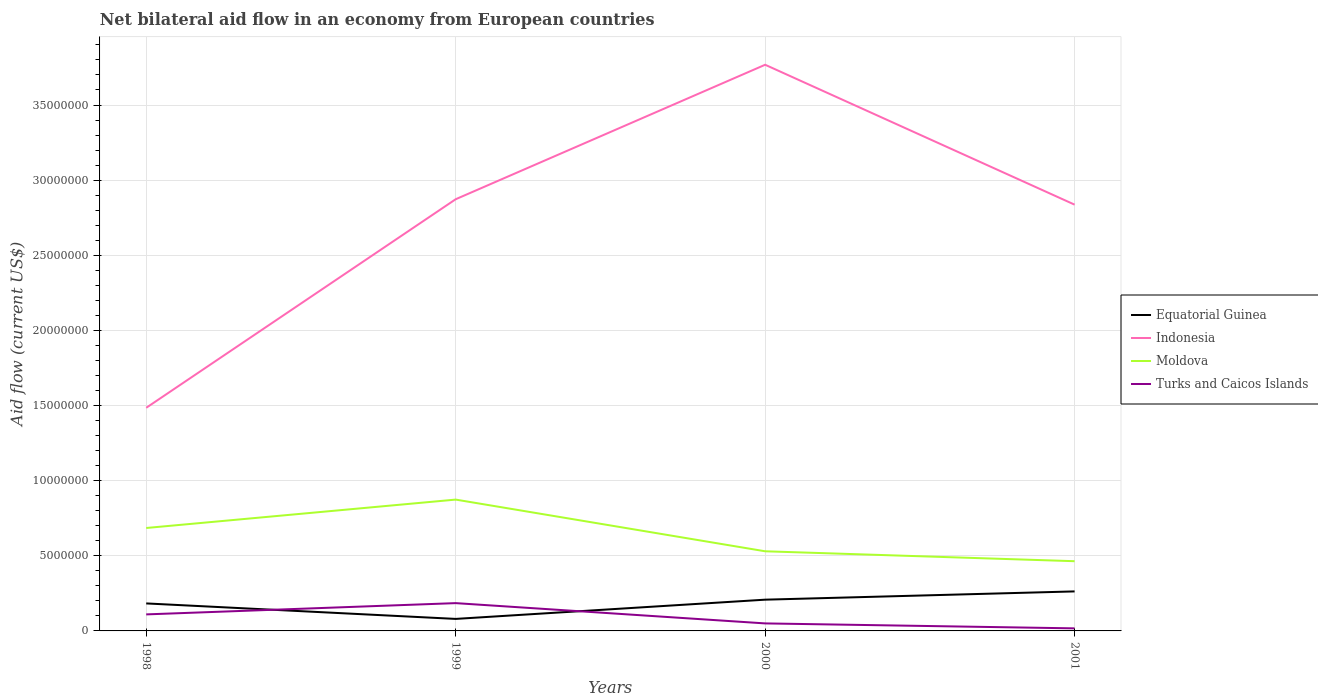Does the line corresponding to Equatorial Guinea intersect with the line corresponding to Indonesia?
Offer a very short reply. No. Across all years, what is the maximum net bilateral aid flow in Turks and Caicos Islands?
Make the answer very short. 1.70e+05. What is the total net bilateral aid flow in Equatorial Guinea in the graph?
Your answer should be very brief. 1.03e+06. What is the difference between the highest and the second highest net bilateral aid flow in Moldova?
Your answer should be very brief. 4.10e+06. How many lines are there?
Make the answer very short. 4. How many years are there in the graph?
Provide a short and direct response. 4. Does the graph contain grids?
Your answer should be very brief. Yes. How are the legend labels stacked?
Provide a short and direct response. Vertical. What is the title of the graph?
Ensure brevity in your answer.  Net bilateral aid flow in an economy from European countries. Does "Panama" appear as one of the legend labels in the graph?
Provide a short and direct response. No. What is the label or title of the X-axis?
Keep it short and to the point. Years. What is the label or title of the Y-axis?
Provide a short and direct response. Aid flow (current US$). What is the Aid flow (current US$) in Equatorial Guinea in 1998?
Offer a very short reply. 1.83e+06. What is the Aid flow (current US$) of Indonesia in 1998?
Make the answer very short. 1.48e+07. What is the Aid flow (current US$) of Moldova in 1998?
Your answer should be very brief. 6.85e+06. What is the Aid flow (current US$) of Turks and Caicos Islands in 1998?
Your answer should be very brief. 1.10e+06. What is the Aid flow (current US$) of Indonesia in 1999?
Keep it short and to the point. 2.87e+07. What is the Aid flow (current US$) of Moldova in 1999?
Your response must be concise. 8.74e+06. What is the Aid flow (current US$) of Turks and Caicos Islands in 1999?
Ensure brevity in your answer.  1.85e+06. What is the Aid flow (current US$) of Equatorial Guinea in 2000?
Ensure brevity in your answer.  2.08e+06. What is the Aid flow (current US$) in Indonesia in 2000?
Offer a very short reply. 3.77e+07. What is the Aid flow (current US$) of Moldova in 2000?
Your answer should be very brief. 5.30e+06. What is the Aid flow (current US$) in Turks and Caicos Islands in 2000?
Make the answer very short. 5.00e+05. What is the Aid flow (current US$) in Equatorial Guinea in 2001?
Your response must be concise. 2.63e+06. What is the Aid flow (current US$) in Indonesia in 2001?
Give a very brief answer. 2.84e+07. What is the Aid flow (current US$) in Moldova in 2001?
Give a very brief answer. 4.64e+06. What is the Aid flow (current US$) of Turks and Caicos Islands in 2001?
Offer a very short reply. 1.70e+05. Across all years, what is the maximum Aid flow (current US$) of Equatorial Guinea?
Provide a succinct answer. 2.63e+06. Across all years, what is the maximum Aid flow (current US$) in Indonesia?
Your response must be concise. 3.77e+07. Across all years, what is the maximum Aid flow (current US$) of Moldova?
Give a very brief answer. 8.74e+06. Across all years, what is the maximum Aid flow (current US$) in Turks and Caicos Islands?
Provide a short and direct response. 1.85e+06. Across all years, what is the minimum Aid flow (current US$) in Equatorial Guinea?
Ensure brevity in your answer.  8.00e+05. Across all years, what is the minimum Aid flow (current US$) in Indonesia?
Provide a succinct answer. 1.48e+07. Across all years, what is the minimum Aid flow (current US$) in Moldova?
Ensure brevity in your answer.  4.64e+06. What is the total Aid flow (current US$) of Equatorial Guinea in the graph?
Offer a very short reply. 7.34e+06. What is the total Aid flow (current US$) of Indonesia in the graph?
Offer a terse response. 1.10e+08. What is the total Aid flow (current US$) of Moldova in the graph?
Keep it short and to the point. 2.55e+07. What is the total Aid flow (current US$) of Turks and Caicos Islands in the graph?
Ensure brevity in your answer.  3.62e+06. What is the difference between the Aid flow (current US$) of Equatorial Guinea in 1998 and that in 1999?
Your response must be concise. 1.03e+06. What is the difference between the Aid flow (current US$) of Indonesia in 1998 and that in 1999?
Make the answer very short. -1.39e+07. What is the difference between the Aid flow (current US$) of Moldova in 1998 and that in 1999?
Keep it short and to the point. -1.89e+06. What is the difference between the Aid flow (current US$) in Turks and Caicos Islands in 1998 and that in 1999?
Give a very brief answer. -7.50e+05. What is the difference between the Aid flow (current US$) in Indonesia in 1998 and that in 2000?
Offer a very short reply. -2.28e+07. What is the difference between the Aid flow (current US$) of Moldova in 1998 and that in 2000?
Provide a succinct answer. 1.55e+06. What is the difference between the Aid flow (current US$) of Turks and Caicos Islands in 1998 and that in 2000?
Provide a succinct answer. 6.00e+05. What is the difference between the Aid flow (current US$) of Equatorial Guinea in 1998 and that in 2001?
Ensure brevity in your answer.  -8.00e+05. What is the difference between the Aid flow (current US$) of Indonesia in 1998 and that in 2001?
Your response must be concise. -1.35e+07. What is the difference between the Aid flow (current US$) of Moldova in 1998 and that in 2001?
Offer a terse response. 2.21e+06. What is the difference between the Aid flow (current US$) in Turks and Caicos Islands in 1998 and that in 2001?
Offer a very short reply. 9.30e+05. What is the difference between the Aid flow (current US$) in Equatorial Guinea in 1999 and that in 2000?
Your answer should be compact. -1.28e+06. What is the difference between the Aid flow (current US$) in Indonesia in 1999 and that in 2000?
Provide a short and direct response. -8.95e+06. What is the difference between the Aid flow (current US$) of Moldova in 1999 and that in 2000?
Keep it short and to the point. 3.44e+06. What is the difference between the Aid flow (current US$) of Turks and Caicos Islands in 1999 and that in 2000?
Your answer should be very brief. 1.35e+06. What is the difference between the Aid flow (current US$) in Equatorial Guinea in 1999 and that in 2001?
Your answer should be compact. -1.83e+06. What is the difference between the Aid flow (current US$) of Indonesia in 1999 and that in 2001?
Your answer should be very brief. 3.60e+05. What is the difference between the Aid flow (current US$) in Moldova in 1999 and that in 2001?
Make the answer very short. 4.10e+06. What is the difference between the Aid flow (current US$) in Turks and Caicos Islands in 1999 and that in 2001?
Your response must be concise. 1.68e+06. What is the difference between the Aid flow (current US$) in Equatorial Guinea in 2000 and that in 2001?
Keep it short and to the point. -5.50e+05. What is the difference between the Aid flow (current US$) in Indonesia in 2000 and that in 2001?
Keep it short and to the point. 9.31e+06. What is the difference between the Aid flow (current US$) in Moldova in 2000 and that in 2001?
Offer a terse response. 6.60e+05. What is the difference between the Aid flow (current US$) in Equatorial Guinea in 1998 and the Aid flow (current US$) in Indonesia in 1999?
Provide a short and direct response. -2.69e+07. What is the difference between the Aid flow (current US$) of Equatorial Guinea in 1998 and the Aid flow (current US$) of Moldova in 1999?
Your response must be concise. -6.91e+06. What is the difference between the Aid flow (current US$) in Equatorial Guinea in 1998 and the Aid flow (current US$) in Turks and Caicos Islands in 1999?
Offer a terse response. -2.00e+04. What is the difference between the Aid flow (current US$) of Indonesia in 1998 and the Aid flow (current US$) of Moldova in 1999?
Your answer should be compact. 6.11e+06. What is the difference between the Aid flow (current US$) in Indonesia in 1998 and the Aid flow (current US$) in Turks and Caicos Islands in 1999?
Your response must be concise. 1.30e+07. What is the difference between the Aid flow (current US$) in Moldova in 1998 and the Aid flow (current US$) in Turks and Caicos Islands in 1999?
Offer a very short reply. 5.00e+06. What is the difference between the Aid flow (current US$) in Equatorial Guinea in 1998 and the Aid flow (current US$) in Indonesia in 2000?
Your answer should be compact. -3.58e+07. What is the difference between the Aid flow (current US$) in Equatorial Guinea in 1998 and the Aid flow (current US$) in Moldova in 2000?
Provide a succinct answer. -3.47e+06. What is the difference between the Aid flow (current US$) in Equatorial Guinea in 1998 and the Aid flow (current US$) in Turks and Caicos Islands in 2000?
Offer a very short reply. 1.33e+06. What is the difference between the Aid flow (current US$) in Indonesia in 1998 and the Aid flow (current US$) in Moldova in 2000?
Ensure brevity in your answer.  9.55e+06. What is the difference between the Aid flow (current US$) in Indonesia in 1998 and the Aid flow (current US$) in Turks and Caicos Islands in 2000?
Your answer should be compact. 1.44e+07. What is the difference between the Aid flow (current US$) in Moldova in 1998 and the Aid flow (current US$) in Turks and Caicos Islands in 2000?
Ensure brevity in your answer.  6.35e+06. What is the difference between the Aid flow (current US$) in Equatorial Guinea in 1998 and the Aid flow (current US$) in Indonesia in 2001?
Provide a short and direct response. -2.65e+07. What is the difference between the Aid flow (current US$) of Equatorial Guinea in 1998 and the Aid flow (current US$) of Moldova in 2001?
Your answer should be compact. -2.81e+06. What is the difference between the Aid flow (current US$) of Equatorial Guinea in 1998 and the Aid flow (current US$) of Turks and Caicos Islands in 2001?
Offer a very short reply. 1.66e+06. What is the difference between the Aid flow (current US$) of Indonesia in 1998 and the Aid flow (current US$) of Moldova in 2001?
Offer a terse response. 1.02e+07. What is the difference between the Aid flow (current US$) of Indonesia in 1998 and the Aid flow (current US$) of Turks and Caicos Islands in 2001?
Make the answer very short. 1.47e+07. What is the difference between the Aid flow (current US$) in Moldova in 1998 and the Aid flow (current US$) in Turks and Caicos Islands in 2001?
Offer a very short reply. 6.68e+06. What is the difference between the Aid flow (current US$) in Equatorial Guinea in 1999 and the Aid flow (current US$) in Indonesia in 2000?
Offer a terse response. -3.69e+07. What is the difference between the Aid flow (current US$) in Equatorial Guinea in 1999 and the Aid flow (current US$) in Moldova in 2000?
Give a very brief answer. -4.50e+06. What is the difference between the Aid flow (current US$) in Equatorial Guinea in 1999 and the Aid flow (current US$) in Turks and Caicos Islands in 2000?
Your answer should be very brief. 3.00e+05. What is the difference between the Aid flow (current US$) of Indonesia in 1999 and the Aid flow (current US$) of Moldova in 2000?
Your response must be concise. 2.34e+07. What is the difference between the Aid flow (current US$) in Indonesia in 1999 and the Aid flow (current US$) in Turks and Caicos Islands in 2000?
Your response must be concise. 2.82e+07. What is the difference between the Aid flow (current US$) of Moldova in 1999 and the Aid flow (current US$) of Turks and Caicos Islands in 2000?
Provide a succinct answer. 8.24e+06. What is the difference between the Aid flow (current US$) of Equatorial Guinea in 1999 and the Aid flow (current US$) of Indonesia in 2001?
Offer a very short reply. -2.76e+07. What is the difference between the Aid flow (current US$) of Equatorial Guinea in 1999 and the Aid flow (current US$) of Moldova in 2001?
Your response must be concise. -3.84e+06. What is the difference between the Aid flow (current US$) in Equatorial Guinea in 1999 and the Aid flow (current US$) in Turks and Caicos Islands in 2001?
Give a very brief answer. 6.30e+05. What is the difference between the Aid flow (current US$) in Indonesia in 1999 and the Aid flow (current US$) in Moldova in 2001?
Make the answer very short. 2.41e+07. What is the difference between the Aid flow (current US$) in Indonesia in 1999 and the Aid flow (current US$) in Turks and Caicos Islands in 2001?
Give a very brief answer. 2.86e+07. What is the difference between the Aid flow (current US$) in Moldova in 1999 and the Aid flow (current US$) in Turks and Caicos Islands in 2001?
Give a very brief answer. 8.57e+06. What is the difference between the Aid flow (current US$) of Equatorial Guinea in 2000 and the Aid flow (current US$) of Indonesia in 2001?
Give a very brief answer. -2.63e+07. What is the difference between the Aid flow (current US$) in Equatorial Guinea in 2000 and the Aid flow (current US$) in Moldova in 2001?
Give a very brief answer. -2.56e+06. What is the difference between the Aid flow (current US$) of Equatorial Guinea in 2000 and the Aid flow (current US$) of Turks and Caicos Islands in 2001?
Your answer should be very brief. 1.91e+06. What is the difference between the Aid flow (current US$) in Indonesia in 2000 and the Aid flow (current US$) in Moldova in 2001?
Provide a short and direct response. 3.30e+07. What is the difference between the Aid flow (current US$) in Indonesia in 2000 and the Aid flow (current US$) in Turks and Caicos Islands in 2001?
Provide a succinct answer. 3.75e+07. What is the difference between the Aid flow (current US$) of Moldova in 2000 and the Aid flow (current US$) of Turks and Caicos Islands in 2001?
Keep it short and to the point. 5.13e+06. What is the average Aid flow (current US$) in Equatorial Guinea per year?
Offer a very short reply. 1.84e+06. What is the average Aid flow (current US$) of Indonesia per year?
Your answer should be compact. 2.74e+07. What is the average Aid flow (current US$) of Moldova per year?
Offer a terse response. 6.38e+06. What is the average Aid flow (current US$) of Turks and Caicos Islands per year?
Give a very brief answer. 9.05e+05. In the year 1998, what is the difference between the Aid flow (current US$) of Equatorial Guinea and Aid flow (current US$) of Indonesia?
Your response must be concise. -1.30e+07. In the year 1998, what is the difference between the Aid flow (current US$) in Equatorial Guinea and Aid flow (current US$) in Moldova?
Your answer should be very brief. -5.02e+06. In the year 1998, what is the difference between the Aid flow (current US$) in Equatorial Guinea and Aid flow (current US$) in Turks and Caicos Islands?
Your response must be concise. 7.30e+05. In the year 1998, what is the difference between the Aid flow (current US$) in Indonesia and Aid flow (current US$) in Turks and Caicos Islands?
Your answer should be compact. 1.38e+07. In the year 1998, what is the difference between the Aid flow (current US$) of Moldova and Aid flow (current US$) of Turks and Caicos Islands?
Your answer should be very brief. 5.75e+06. In the year 1999, what is the difference between the Aid flow (current US$) in Equatorial Guinea and Aid flow (current US$) in Indonesia?
Keep it short and to the point. -2.79e+07. In the year 1999, what is the difference between the Aid flow (current US$) in Equatorial Guinea and Aid flow (current US$) in Moldova?
Provide a succinct answer. -7.94e+06. In the year 1999, what is the difference between the Aid flow (current US$) in Equatorial Guinea and Aid flow (current US$) in Turks and Caicos Islands?
Ensure brevity in your answer.  -1.05e+06. In the year 1999, what is the difference between the Aid flow (current US$) in Indonesia and Aid flow (current US$) in Moldova?
Give a very brief answer. 2.00e+07. In the year 1999, what is the difference between the Aid flow (current US$) of Indonesia and Aid flow (current US$) of Turks and Caicos Islands?
Give a very brief answer. 2.69e+07. In the year 1999, what is the difference between the Aid flow (current US$) in Moldova and Aid flow (current US$) in Turks and Caicos Islands?
Your response must be concise. 6.89e+06. In the year 2000, what is the difference between the Aid flow (current US$) of Equatorial Guinea and Aid flow (current US$) of Indonesia?
Your answer should be very brief. -3.56e+07. In the year 2000, what is the difference between the Aid flow (current US$) of Equatorial Guinea and Aid flow (current US$) of Moldova?
Your response must be concise. -3.22e+06. In the year 2000, what is the difference between the Aid flow (current US$) in Equatorial Guinea and Aid flow (current US$) in Turks and Caicos Islands?
Provide a succinct answer. 1.58e+06. In the year 2000, what is the difference between the Aid flow (current US$) in Indonesia and Aid flow (current US$) in Moldova?
Give a very brief answer. 3.24e+07. In the year 2000, what is the difference between the Aid flow (current US$) in Indonesia and Aid flow (current US$) in Turks and Caicos Islands?
Make the answer very short. 3.72e+07. In the year 2000, what is the difference between the Aid flow (current US$) in Moldova and Aid flow (current US$) in Turks and Caicos Islands?
Keep it short and to the point. 4.80e+06. In the year 2001, what is the difference between the Aid flow (current US$) of Equatorial Guinea and Aid flow (current US$) of Indonesia?
Your answer should be compact. -2.57e+07. In the year 2001, what is the difference between the Aid flow (current US$) of Equatorial Guinea and Aid flow (current US$) of Moldova?
Your answer should be very brief. -2.01e+06. In the year 2001, what is the difference between the Aid flow (current US$) in Equatorial Guinea and Aid flow (current US$) in Turks and Caicos Islands?
Your response must be concise. 2.46e+06. In the year 2001, what is the difference between the Aid flow (current US$) in Indonesia and Aid flow (current US$) in Moldova?
Your answer should be very brief. 2.37e+07. In the year 2001, what is the difference between the Aid flow (current US$) in Indonesia and Aid flow (current US$) in Turks and Caicos Islands?
Provide a succinct answer. 2.82e+07. In the year 2001, what is the difference between the Aid flow (current US$) of Moldova and Aid flow (current US$) of Turks and Caicos Islands?
Ensure brevity in your answer.  4.47e+06. What is the ratio of the Aid flow (current US$) in Equatorial Guinea in 1998 to that in 1999?
Your answer should be compact. 2.29. What is the ratio of the Aid flow (current US$) of Indonesia in 1998 to that in 1999?
Offer a very short reply. 0.52. What is the ratio of the Aid flow (current US$) in Moldova in 1998 to that in 1999?
Your response must be concise. 0.78. What is the ratio of the Aid flow (current US$) of Turks and Caicos Islands in 1998 to that in 1999?
Keep it short and to the point. 0.59. What is the ratio of the Aid flow (current US$) of Equatorial Guinea in 1998 to that in 2000?
Keep it short and to the point. 0.88. What is the ratio of the Aid flow (current US$) in Indonesia in 1998 to that in 2000?
Offer a terse response. 0.39. What is the ratio of the Aid flow (current US$) of Moldova in 1998 to that in 2000?
Your response must be concise. 1.29. What is the ratio of the Aid flow (current US$) in Equatorial Guinea in 1998 to that in 2001?
Your response must be concise. 0.7. What is the ratio of the Aid flow (current US$) in Indonesia in 1998 to that in 2001?
Your answer should be compact. 0.52. What is the ratio of the Aid flow (current US$) in Moldova in 1998 to that in 2001?
Provide a succinct answer. 1.48. What is the ratio of the Aid flow (current US$) in Turks and Caicos Islands in 1998 to that in 2001?
Ensure brevity in your answer.  6.47. What is the ratio of the Aid flow (current US$) of Equatorial Guinea in 1999 to that in 2000?
Provide a short and direct response. 0.38. What is the ratio of the Aid flow (current US$) of Indonesia in 1999 to that in 2000?
Ensure brevity in your answer.  0.76. What is the ratio of the Aid flow (current US$) in Moldova in 1999 to that in 2000?
Your answer should be very brief. 1.65. What is the ratio of the Aid flow (current US$) in Turks and Caicos Islands in 1999 to that in 2000?
Provide a short and direct response. 3.7. What is the ratio of the Aid flow (current US$) in Equatorial Guinea in 1999 to that in 2001?
Offer a very short reply. 0.3. What is the ratio of the Aid flow (current US$) of Indonesia in 1999 to that in 2001?
Provide a short and direct response. 1.01. What is the ratio of the Aid flow (current US$) of Moldova in 1999 to that in 2001?
Offer a terse response. 1.88. What is the ratio of the Aid flow (current US$) in Turks and Caicos Islands in 1999 to that in 2001?
Your answer should be compact. 10.88. What is the ratio of the Aid flow (current US$) of Equatorial Guinea in 2000 to that in 2001?
Offer a very short reply. 0.79. What is the ratio of the Aid flow (current US$) in Indonesia in 2000 to that in 2001?
Your answer should be compact. 1.33. What is the ratio of the Aid flow (current US$) of Moldova in 2000 to that in 2001?
Ensure brevity in your answer.  1.14. What is the ratio of the Aid flow (current US$) in Turks and Caicos Islands in 2000 to that in 2001?
Your answer should be compact. 2.94. What is the difference between the highest and the second highest Aid flow (current US$) in Equatorial Guinea?
Offer a very short reply. 5.50e+05. What is the difference between the highest and the second highest Aid flow (current US$) of Indonesia?
Your response must be concise. 8.95e+06. What is the difference between the highest and the second highest Aid flow (current US$) of Moldova?
Make the answer very short. 1.89e+06. What is the difference between the highest and the second highest Aid flow (current US$) in Turks and Caicos Islands?
Provide a short and direct response. 7.50e+05. What is the difference between the highest and the lowest Aid flow (current US$) in Equatorial Guinea?
Provide a short and direct response. 1.83e+06. What is the difference between the highest and the lowest Aid flow (current US$) of Indonesia?
Give a very brief answer. 2.28e+07. What is the difference between the highest and the lowest Aid flow (current US$) of Moldova?
Your response must be concise. 4.10e+06. What is the difference between the highest and the lowest Aid flow (current US$) of Turks and Caicos Islands?
Offer a very short reply. 1.68e+06. 